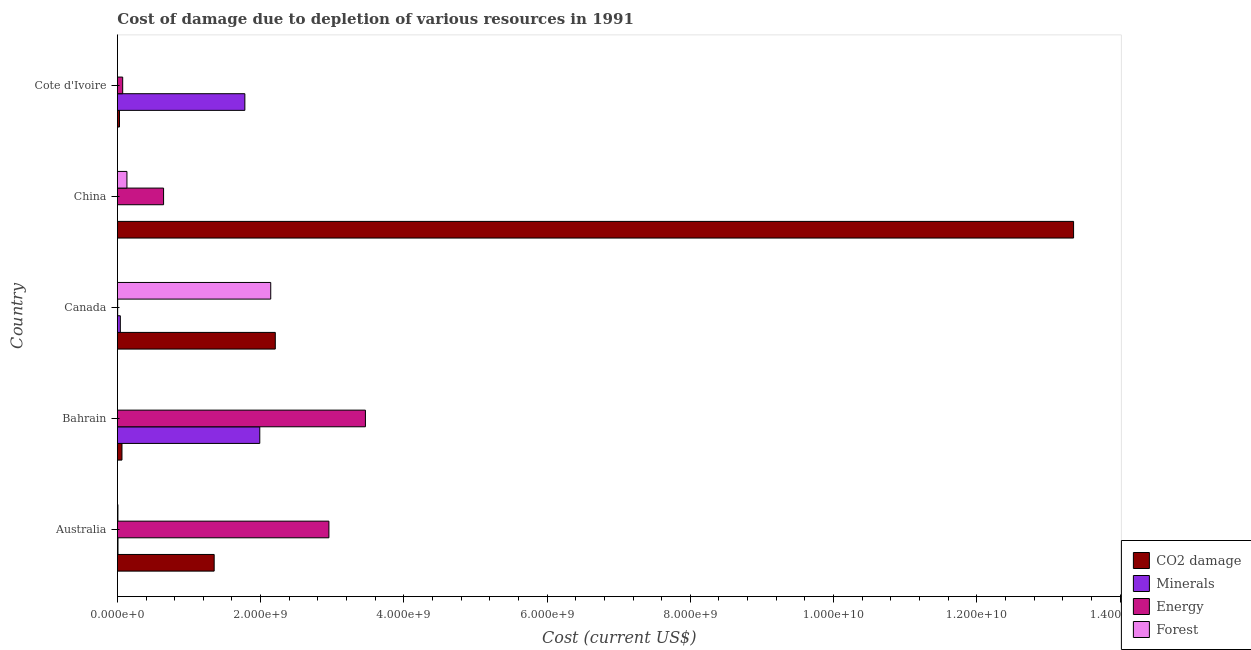How many different coloured bars are there?
Your answer should be very brief. 4. Are the number of bars on each tick of the Y-axis equal?
Make the answer very short. Yes. How many bars are there on the 4th tick from the top?
Provide a succinct answer. 4. What is the label of the 5th group of bars from the top?
Give a very brief answer. Australia. What is the cost of damage due to depletion of energy in Cote d'Ivoire?
Provide a succinct answer. 7.38e+07. Across all countries, what is the maximum cost of damage due to depletion of minerals?
Ensure brevity in your answer.  1.99e+09. Across all countries, what is the minimum cost of damage due to depletion of coal?
Keep it short and to the point. 2.91e+07. In which country was the cost of damage due to depletion of minerals maximum?
Your answer should be very brief. Bahrain. In which country was the cost of damage due to depletion of forests minimum?
Ensure brevity in your answer.  Bahrain. What is the total cost of damage due to depletion of minerals in the graph?
Keep it short and to the point. 3.82e+09. What is the difference between the cost of damage due to depletion of minerals in Bahrain and that in China?
Your response must be concise. 1.99e+09. What is the difference between the cost of damage due to depletion of forests in Cote d'Ivoire and the cost of damage due to depletion of coal in Bahrain?
Provide a succinct answer. -6.35e+07. What is the average cost of damage due to depletion of minerals per country?
Keep it short and to the point. 7.63e+08. What is the difference between the cost of damage due to depletion of coal and cost of damage due to depletion of forests in Australia?
Offer a very short reply. 1.34e+09. In how many countries, is the cost of damage due to depletion of minerals greater than 12800000000 US$?
Ensure brevity in your answer.  0. What is the ratio of the cost of damage due to depletion of forests in Canada to that in China?
Your answer should be very brief. 16.08. What is the difference between the highest and the second highest cost of damage due to depletion of coal?
Ensure brevity in your answer.  1.11e+1. What is the difference between the highest and the lowest cost of damage due to depletion of minerals?
Offer a very short reply. 1.99e+09. Is the sum of the cost of damage due to depletion of minerals in Bahrain and Cote d'Ivoire greater than the maximum cost of damage due to depletion of forests across all countries?
Provide a short and direct response. Yes. Is it the case that in every country, the sum of the cost of damage due to depletion of energy and cost of damage due to depletion of minerals is greater than the sum of cost of damage due to depletion of coal and cost of damage due to depletion of forests?
Offer a very short reply. No. What does the 1st bar from the top in Canada represents?
Your answer should be very brief. Forest. What does the 2nd bar from the bottom in Bahrain represents?
Your response must be concise. Minerals. How many bars are there?
Your answer should be compact. 20. Are all the bars in the graph horizontal?
Ensure brevity in your answer.  Yes. What is the difference between two consecutive major ticks on the X-axis?
Give a very brief answer. 2.00e+09. Are the values on the major ticks of X-axis written in scientific E-notation?
Offer a very short reply. Yes. Where does the legend appear in the graph?
Your response must be concise. Bottom right. How are the legend labels stacked?
Ensure brevity in your answer.  Vertical. What is the title of the graph?
Your answer should be very brief. Cost of damage due to depletion of various resources in 1991 . What is the label or title of the X-axis?
Provide a succinct answer. Cost (current US$). What is the label or title of the Y-axis?
Provide a succinct answer. Country. What is the Cost (current US$) of CO2 damage in Australia?
Offer a terse response. 1.35e+09. What is the Cost (current US$) in Minerals in Australia?
Your answer should be compact. 8.34e+06. What is the Cost (current US$) of Energy in Australia?
Offer a terse response. 2.95e+09. What is the Cost (current US$) in Forest in Australia?
Your answer should be very brief. 7.24e+06. What is the Cost (current US$) in CO2 damage in Bahrain?
Provide a short and direct response. 6.37e+07. What is the Cost (current US$) in Minerals in Bahrain?
Provide a short and direct response. 1.99e+09. What is the Cost (current US$) of Energy in Bahrain?
Provide a short and direct response. 3.46e+09. What is the Cost (current US$) of Forest in Bahrain?
Give a very brief answer. 1.90e+05. What is the Cost (current US$) in CO2 damage in Canada?
Provide a short and direct response. 2.20e+09. What is the Cost (current US$) in Minerals in Canada?
Make the answer very short. 4.08e+07. What is the Cost (current US$) of Energy in Canada?
Make the answer very short. 3.73e+06. What is the Cost (current US$) of Forest in Canada?
Your response must be concise. 2.14e+09. What is the Cost (current US$) of CO2 damage in China?
Your answer should be very brief. 1.34e+1. What is the Cost (current US$) in Minerals in China?
Ensure brevity in your answer.  5762.35. What is the Cost (current US$) of Energy in China?
Provide a short and direct response. 6.45e+08. What is the Cost (current US$) of Forest in China?
Offer a terse response. 1.33e+08. What is the Cost (current US$) of CO2 damage in Cote d'Ivoire?
Ensure brevity in your answer.  2.91e+07. What is the Cost (current US$) of Minerals in Cote d'Ivoire?
Ensure brevity in your answer.  1.78e+09. What is the Cost (current US$) in Energy in Cote d'Ivoire?
Provide a succinct answer. 7.38e+07. What is the Cost (current US$) in Forest in Cote d'Ivoire?
Keep it short and to the point. 2.44e+05. Across all countries, what is the maximum Cost (current US$) of CO2 damage?
Your response must be concise. 1.34e+1. Across all countries, what is the maximum Cost (current US$) in Minerals?
Your answer should be compact. 1.99e+09. Across all countries, what is the maximum Cost (current US$) of Energy?
Your answer should be very brief. 3.46e+09. Across all countries, what is the maximum Cost (current US$) of Forest?
Ensure brevity in your answer.  2.14e+09. Across all countries, what is the minimum Cost (current US$) of CO2 damage?
Your answer should be very brief. 2.91e+07. Across all countries, what is the minimum Cost (current US$) in Minerals?
Give a very brief answer. 5762.35. Across all countries, what is the minimum Cost (current US$) in Energy?
Your answer should be very brief. 3.73e+06. Across all countries, what is the minimum Cost (current US$) in Forest?
Offer a very short reply. 1.90e+05. What is the total Cost (current US$) of CO2 damage in the graph?
Your answer should be very brief. 1.70e+1. What is the total Cost (current US$) in Minerals in the graph?
Your answer should be very brief. 3.82e+09. What is the total Cost (current US$) in Energy in the graph?
Provide a short and direct response. 7.14e+09. What is the total Cost (current US$) in Forest in the graph?
Make the answer very short. 2.28e+09. What is the difference between the Cost (current US$) in CO2 damage in Australia and that in Bahrain?
Give a very brief answer. 1.29e+09. What is the difference between the Cost (current US$) of Minerals in Australia and that in Bahrain?
Give a very brief answer. -1.98e+09. What is the difference between the Cost (current US$) in Energy in Australia and that in Bahrain?
Keep it short and to the point. -5.10e+08. What is the difference between the Cost (current US$) of Forest in Australia and that in Bahrain?
Offer a very short reply. 7.05e+06. What is the difference between the Cost (current US$) in CO2 damage in Australia and that in Canada?
Your answer should be compact. -8.53e+08. What is the difference between the Cost (current US$) in Minerals in Australia and that in Canada?
Give a very brief answer. -3.24e+07. What is the difference between the Cost (current US$) in Energy in Australia and that in Canada?
Keep it short and to the point. 2.95e+09. What is the difference between the Cost (current US$) of Forest in Australia and that in Canada?
Your answer should be compact. -2.13e+09. What is the difference between the Cost (current US$) of CO2 damage in Australia and that in China?
Offer a terse response. -1.20e+1. What is the difference between the Cost (current US$) in Minerals in Australia and that in China?
Give a very brief answer. 8.33e+06. What is the difference between the Cost (current US$) in Energy in Australia and that in China?
Ensure brevity in your answer.  2.31e+09. What is the difference between the Cost (current US$) in Forest in Australia and that in China?
Keep it short and to the point. -1.26e+08. What is the difference between the Cost (current US$) of CO2 damage in Australia and that in Cote d'Ivoire?
Ensure brevity in your answer.  1.32e+09. What is the difference between the Cost (current US$) of Minerals in Australia and that in Cote d'Ivoire?
Ensure brevity in your answer.  -1.77e+09. What is the difference between the Cost (current US$) in Energy in Australia and that in Cote d'Ivoire?
Offer a terse response. 2.88e+09. What is the difference between the Cost (current US$) of Forest in Australia and that in Cote d'Ivoire?
Offer a terse response. 7.00e+06. What is the difference between the Cost (current US$) of CO2 damage in Bahrain and that in Canada?
Your answer should be very brief. -2.14e+09. What is the difference between the Cost (current US$) of Minerals in Bahrain and that in Canada?
Provide a succinct answer. 1.95e+09. What is the difference between the Cost (current US$) in Energy in Bahrain and that in Canada?
Your answer should be very brief. 3.46e+09. What is the difference between the Cost (current US$) in Forest in Bahrain and that in Canada?
Make the answer very short. -2.14e+09. What is the difference between the Cost (current US$) of CO2 damage in Bahrain and that in China?
Ensure brevity in your answer.  -1.33e+1. What is the difference between the Cost (current US$) of Minerals in Bahrain and that in China?
Provide a succinct answer. 1.99e+09. What is the difference between the Cost (current US$) in Energy in Bahrain and that in China?
Your answer should be compact. 2.82e+09. What is the difference between the Cost (current US$) of Forest in Bahrain and that in China?
Your answer should be very brief. -1.33e+08. What is the difference between the Cost (current US$) in CO2 damage in Bahrain and that in Cote d'Ivoire?
Offer a very short reply. 3.46e+07. What is the difference between the Cost (current US$) in Minerals in Bahrain and that in Cote d'Ivoire?
Offer a very short reply. 2.08e+08. What is the difference between the Cost (current US$) in Energy in Bahrain and that in Cote d'Ivoire?
Keep it short and to the point. 3.39e+09. What is the difference between the Cost (current US$) of Forest in Bahrain and that in Cote d'Ivoire?
Your answer should be compact. -5.42e+04. What is the difference between the Cost (current US$) in CO2 damage in Canada and that in China?
Your answer should be compact. -1.11e+1. What is the difference between the Cost (current US$) in Minerals in Canada and that in China?
Your answer should be compact. 4.08e+07. What is the difference between the Cost (current US$) of Energy in Canada and that in China?
Offer a very short reply. -6.41e+08. What is the difference between the Cost (current US$) of Forest in Canada and that in China?
Ensure brevity in your answer.  2.01e+09. What is the difference between the Cost (current US$) of CO2 damage in Canada and that in Cote d'Ivoire?
Keep it short and to the point. 2.18e+09. What is the difference between the Cost (current US$) of Minerals in Canada and that in Cote d'Ivoire?
Offer a terse response. -1.74e+09. What is the difference between the Cost (current US$) in Energy in Canada and that in Cote d'Ivoire?
Make the answer very short. -7.01e+07. What is the difference between the Cost (current US$) in Forest in Canada and that in Cote d'Ivoire?
Give a very brief answer. 2.14e+09. What is the difference between the Cost (current US$) in CO2 damage in China and that in Cote d'Ivoire?
Your answer should be very brief. 1.33e+1. What is the difference between the Cost (current US$) of Minerals in China and that in Cote d'Ivoire?
Make the answer very short. -1.78e+09. What is the difference between the Cost (current US$) of Energy in China and that in Cote d'Ivoire?
Offer a very short reply. 5.71e+08. What is the difference between the Cost (current US$) of Forest in China and that in Cote d'Ivoire?
Provide a short and direct response. 1.33e+08. What is the difference between the Cost (current US$) in CO2 damage in Australia and the Cost (current US$) in Minerals in Bahrain?
Offer a terse response. -6.37e+08. What is the difference between the Cost (current US$) in CO2 damage in Australia and the Cost (current US$) in Energy in Bahrain?
Keep it short and to the point. -2.11e+09. What is the difference between the Cost (current US$) in CO2 damage in Australia and the Cost (current US$) in Forest in Bahrain?
Keep it short and to the point. 1.35e+09. What is the difference between the Cost (current US$) in Minerals in Australia and the Cost (current US$) in Energy in Bahrain?
Your answer should be compact. -3.45e+09. What is the difference between the Cost (current US$) of Minerals in Australia and the Cost (current US$) of Forest in Bahrain?
Offer a very short reply. 8.15e+06. What is the difference between the Cost (current US$) in Energy in Australia and the Cost (current US$) in Forest in Bahrain?
Offer a very short reply. 2.95e+09. What is the difference between the Cost (current US$) of CO2 damage in Australia and the Cost (current US$) of Minerals in Canada?
Give a very brief answer. 1.31e+09. What is the difference between the Cost (current US$) of CO2 damage in Australia and the Cost (current US$) of Energy in Canada?
Your answer should be compact. 1.35e+09. What is the difference between the Cost (current US$) in CO2 damage in Australia and the Cost (current US$) in Forest in Canada?
Provide a succinct answer. -7.90e+08. What is the difference between the Cost (current US$) of Minerals in Australia and the Cost (current US$) of Energy in Canada?
Give a very brief answer. 4.61e+06. What is the difference between the Cost (current US$) in Minerals in Australia and the Cost (current US$) in Forest in Canada?
Make the answer very short. -2.13e+09. What is the difference between the Cost (current US$) in Energy in Australia and the Cost (current US$) in Forest in Canada?
Provide a short and direct response. 8.12e+08. What is the difference between the Cost (current US$) of CO2 damage in Australia and the Cost (current US$) of Minerals in China?
Your answer should be compact. 1.35e+09. What is the difference between the Cost (current US$) in CO2 damage in Australia and the Cost (current US$) in Energy in China?
Give a very brief answer. 7.06e+08. What is the difference between the Cost (current US$) of CO2 damage in Australia and the Cost (current US$) of Forest in China?
Offer a very short reply. 1.22e+09. What is the difference between the Cost (current US$) of Minerals in Australia and the Cost (current US$) of Energy in China?
Your response must be concise. -6.37e+08. What is the difference between the Cost (current US$) in Minerals in Australia and the Cost (current US$) in Forest in China?
Offer a very short reply. -1.25e+08. What is the difference between the Cost (current US$) of Energy in Australia and the Cost (current US$) of Forest in China?
Your response must be concise. 2.82e+09. What is the difference between the Cost (current US$) of CO2 damage in Australia and the Cost (current US$) of Minerals in Cote d'Ivoire?
Your answer should be compact. -4.28e+08. What is the difference between the Cost (current US$) in CO2 damage in Australia and the Cost (current US$) in Energy in Cote d'Ivoire?
Offer a very short reply. 1.28e+09. What is the difference between the Cost (current US$) of CO2 damage in Australia and the Cost (current US$) of Forest in Cote d'Ivoire?
Ensure brevity in your answer.  1.35e+09. What is the difference between the Cost (current US$) of Minerals in Australia and the Cost (current US$) of Energy in Cote d'Ivoire?
Offer a very short reply. -6.55e+07. What is the difference between the Cost (current US$) in Minerals in Australia and the Cost (current US$) in Forest in Cote d'Ivoire?
Provide a short and direct response. 8.09e+06. What is the difference between the Cost (current US$) in Energy in Australia and the Cost (current US$) in Forest in Cote d'Ivoire?
Ensure brevity in your answer.  2.95e+09. What is the difference between the Cost (current US$) of CO2 damage in Bahrain and the Cost (current US$) of Minerals in Canada?
Give a very brief answer. 2.29e+07. What is the difference between the Cost (current US$) of CO2 damage in Bahrain and the Cost (current US$) of Energy in Canada?
Your answer should be very brief. 6.00e+07. What is the difference between the Cost (current US$) in CO2 damage in Bahrain and the Cost (current US$) in Forest in Canada?
Your answer should be very brief. -2.08e+09. What is the difference between the Cost (current US$) in Minerals in Bahrain and the Cost (current US$) in Energy in Canada?
Provide a succinct answer. 1.98e+09. What is the difference between the Cost (current US$) in Minerals in Bahrain and the Cost (current US$) in Forest in Canada?
Offer a terse response. -1.53e+08. What is the difference between the Cost (current US$) in Energy in Bahrain and the Cost (current US$) in Forest in Canada?
Your answer should be compact. 1.32e+09. What is the difference between the Cost (current US$) of CO2 damage in Bahrain and the Cost (current US$) of Minerals in China?
Your answer should be compact. 6.37e+07. What is the difference between the Cost (current US$) of CO2 damage in Bahrain and the Cost (current US$) of Energy in China?
Your answer should be very brief. -5.81e+08. What is the difference between the Cost (current US$) of CO2 damage in Bahrain and the Cost (current US$) of Forest in China?
Keep it short and to the point. -6.94e+07. What is the difference between the Cost (current US$) in Minerals in Bahrain and the Cost (current US$) in Energy in China?
Provide a succinct answer. 1.34e+09. What is the difference between the Cost (current US$) in Minerals in Bahrain and the Cost (current US$) in Forest in China?
Give a very brief answer. 1.86e+09. What is the difference between the Cost (current US$) of Energy in Bahrain and the Cost (current US$) of Forest in China?
Your answer should be compact. 3.33e+09. What is the difference between the Cost (current US$) of CO2 damage in Bahrain and the Cost (current US$) of Minerals in Cote d'Ivoire?
Your answer should be very brief. -1.72e+09. What is the difference between the Cost (current US$) in CO2 damage in Bahrain and the Cost (current US$) in Energy in Cote d'Ivoire?
Give a very brief answer. -1.01e+07. What is the difference between the Cost (current US$) in CO2 damage in Bahrain and the Cost (current US$) in Forest in Cote d'Ivoire?
Your answer should be very brief. 6.35e+07. What is the difference between the Cost (current US$) of Minerals in Bahrain and the Cost (current US$) of Energy in Cote d'Ivoire?
Keep it short and to the point. 1.91e+09. What is the difference between the Cost (current US$) of Minerals in Bahrain and the Cost (current US$) of Forest in Cote d'Ivoire?
Ensure brevity in your answer.  1.99e+09. What is the difference between the Cost (current US$) of Energy in Bahrain and the Cost (current US$) of Forest in Cote d'Ivoire?
Your answer should be very brief. 3.46e+09. What is the difference between the Cost (current US$) in CO2 damage in Canada and the Cost (current US$) in Minerals in China?
Offer a very short reply. 2.20e+09. What is the difference between the Cost (current US$) of CO2 damage in Canada and the Cost (current US$) of Energy in China?
Your answer should be compact. 1.56e+09. What is the difference between the Cost (current US$) of CO2 damage in Canada and the Cost (current US$) of Forest in China?
Offer a very short reply. 2.07e+09. What is the difference between the Cost (current US$) in Minerals in Canada and the Cost (current US$) in Energy in China?
Make the answer very short. -6.04e+08. What is the difference between the Cost (current US$) in Minerals in Canada and the Cost (current US$) in Forest in China?
Give a very brief answer. -9.24e+07. What is the difference between the Cost (current US$) in Energy in Canada and the Cost (current US$) in Forest in China?
Provide a short and direct response. -1.29e+08. What is the difference between the Cost (current US$) of CO2 damage in Canada and the Cost (current US$) of Minerals in Cote d'Ivoire?
Offer a very short reply. 4.25e+08. What is the difference between the Cost (current US$) in CO2 damage in Canada and the Cost (current US$) in Energy in Cote d'Ivoire?
Provide a succinct answer. 2.13e+09. What is the difference between the Cost (current US$) of CO2 damage in Canada and the Cost (current US$) of Forest in Cote d'Ivoire?
Your answer should be compact. 2.20e+09. What is the difference between the Cost (current US$) in Minerals in Canada and the Cost (current US$) in Energy in Cote d'Ivoire?
Keep it short and to the point. -3.31e+07. What is the difference between the Cost (current US$) in Minerals in Canada and the Cost (current US$) in Forest in Cote d'Ivoire?
Make the answer very short. 4.05e+07. What is the difference between the Cost (current US$) of Energy in Canada and the Cost (current US$) of Forest in Cote d'Ivoire?
Provide a short and direct response. 3.48e+06. What is the difference between the Cost (current US$) of CO2 damage in China and the Cost (current US$) of Minerals in Cote d'Ivoire?
Provide a succinct answer. 1.16e+1. What is the difference between the Cost (current US$) in CO2 damage in China and the Cost (current US$) in Energy in Cote d'Ivoire?
Provide a succinct answer. 1.33e+1. What is the difference between the Cost (current US$) in CO2 damage in China and the Cost (current US$) in Forest in Cote d'Ivoire?
Your response must be concise. 1.34e+1. What is the difference between the Cost (current US$) of Minerals in China and the Cost (current US$) of Energy in Cote d'Ivoire?
Your response must be concise. -7.38e+07. What is the difference between the Cost (current US$) of Minerals in China and the Cost (current US$) of Forest in Cote d'Ivoire?
Ensure brevity in your answer.  -2.39e+05. What is the difference between the Cost (current US$) in Energy in China and the Cost (current US$) in Forest in Cote d'Ivoire?
Provide a succinct answer. 6.45e+08. What is the average Cost (current US$) of CO2 damage per country?
Give a very brief answer. 3.40e+09. What is the average Cost (current US$) in Minerals per country?
Your response must be concise. 7.63e+08. What is the average Cost (current US$) in Energy per country?
Ensure brevity in your answer.  1.43e+09. What is the average Cost (current US$) of Forest per country?
Your answer should be very brief. 4.56e+08. What is the difference between the Cost (current US$) of CO2 damage and Cost (current US$) of Minerals in Australia?
Offer a terse response. 1.34e+09. What is the difference between the Cost (current US$) in CO2 damage and Cost (current US$) in Energy in Australia?
Give a very brief answer. -1.60e+09. What is the difference between the Cost (current US$) in CO2 damage and Cost (current US$) in Forest in Australia?
Keep it short and to the point. 1.34e+09. What is the difference between the Cost (current US$) in Minerals and Cost (current US$) in Energy in Australia?
Your answer should be compact. -2.95e+09. What is the difference between the Cost (current US$) in Minerals and Cost (current US$) in Forest in Australia?
Ensure brevity in your answer.  1.10e+06. What is the difference between the Cost (current US$) of Energy and Cost (current US$) of Forest in Australia?
Your answer should be compact. 2.95e+09. What is the difference between the Cost (current US$) in CO2 damage and Cost (current US$) in Minerals in Bahrain?
Give a very brief answer. -1.92e+09. What is the difference between the Cost (current US$) in CO2 damage and Cost (current US$) in Energy in Bahrain?
Keep it short and to the point. -3.40e+09. What is the difference between the Cost (current US$) of CO2 damage and Cost (current US$) of Forest in Bahrain?
Keep it short and to the point. 6.35e+07. What is the difference between the Cost (current US$) in Minerals and Cost (current US$) in Energy in Bahrain?
Offer a terse response. -1.48e+09. What is the difference between the Cost (current US$) of Minerals and Cost (current US$) of Forest in Bahrain?
Give a very brief answer. 1.99e+09. What is the difference between the Cost (current US$) in Energy and Cost (current US$) in Forest in Bahrain?
Your response must be concise. 3.46e+09. What is the difference between the Cost (current US$) in CO2 damage and Cost (current US$) in Minerals in Canada?
Make the answer very short. 2.16e+09. What is the difference between the Cost (current US$) of CO2 damage and Cost (current US$) of Energy in Canada?
Offer a very short reply. 2.20e+09. What is the difference between the Cost (current US$) in CO2 damage and Cost (current US$) in Forest in Canada?
Ensure brevity in your answer.  6.37e+07. What is the difference between the Cost (current US$) of Minerals and Cost (current US$) of Energy in Canada?
Keep it short and to the point. 3.71e+07. What is the difference between the Cost (current US$) in Minerals and Cost (current US$) in Forest in Canada?
Provide a succinct answer. -2.10e+09. What is the difference between the Cost (current US$) of Energy and Cost (current US$) of Forest in Canada?
Make the answer very short. -2.14e+09. What is the difference between the Cost (current US$) of CO2 damage and Cost (current US$) of Minerals in China?
Provide a short and direct response. 1.34e+1. What is the difference between the Cost (current US$) of CO2 damage and Cost (current US$) of Energy in China?
Give a very brief answer. 1.27e+1. What is the difference between the Cost (current US$) of CO2 damage and Cost (current US$) of Forest in China?
Offer a very short reply. 1.32e+1. What is the difference between the Cost (current US$) in Minerals and Cost (current US$) in Energy in China?
Give a very brief answer. -6.45e+08. What is the difference between the Cost (current US$) in Minerals and Cost (current US$) in Forest in China?
Ensure brevity in your answer.  -1.33e+08. What is the difference between the Cost (current US$) of Energy and Cost (current US$) of Forest in China?
Make the answer very short. 5.12e+08. What is the difference between the Cost (current US$) of CO2 damage and Cost (current US$) of Minerals in Cote d'Ivoire?
Offer a terse response. -1.75e+09. What is the difference between the Cost (current US$) of CO2 damage and Cost (current US$) of Energy in Cote d'Ivoire?
Offer a terse response. -4.47e+07. What is the difference between the Cost (current US$) of CO2 damage and Cost (current US$) of Forest in Cote d'Ivoire?
Offer a very short reply. 2.89e+07. What is the difference between the Cost (current US$) of Minerals and Cost (current US$) of Energy in Cote d'Ivoire?
Provide a short and direct response. 1.71e+09. What is the difference between the Cost (current US$) in Minerals and Cost (current US$) in Forest in Cote d'Ivoire?
Your answer should be compact. 1.78e+09. What is the difference between the Cost (current US$) of Energy and Cost (current US$) of Forest in Cote d'Ivoire?
Offer a very short reply. 7.36e+07. What is the ratio of the Cost (current US$) in CO2 damage in Australia to that in Bahrain?
Make the answer very short. 21.2. What is the ratio of the Cost (current US$) in Minerals in Australia to that in Bahrain?
Keep it short and to the point. 0. What is the ratio of the Cost (current US$) of Energy in Australia to that in Bahrain?
Your answer should be compact. 0.85. What is the ratio of the Cost (current US$) in Forest in Australia to that in Bahrain?
Offer a terse response. 38.1. What is the ratio of the Cost (current US$) in CO2 damage in Australia to that in Canada?
Ensure brevity in your answer.  0.61. What is the ratio of the Cost (current US$) in Minerals in Australia to that in Canada?
Provide a succinct answer. 0.2. What is the ratio of the Cost (current US$) in Energy in Australia to that in Canada?
Your answer should be very brief. 792.69. What is the ratio of the Cost (current US$) in Forest in Australia to that in Canada?
Your answer should be compact. 0. What is the ratio of the Cost (current US$) of CO2 damage in Australia to that in China?
Ensure brevity in your answer.  0.1. What is the ratio of the Cost (current US$) in Minerals in Australia to that in China?
Ensure brevity in your answer.  1447.04. What is the ratio of the Cost (current US$) of Energy in Australia to that in China?
Your response must be concise. 4.58. What is the ratio of the Cost (current US$) in Forest in Australia to that in China?
Your answer should be very brief. 0.05. What is the ratio of the Cost (current US$) of CO2 damage in Australia to that in Cote d'Ivoire?
Your answer should be compact. 46.41. What is the ratio of the Cost (current US$) in Minerals in Australia to that in Cote d'Ivoire?
Provide a succinct answer. 0. What is the ratio of the Cost (current US$) in Energy in Australia to that in Cote d'Ivoire?
Offer a terse response. 40. What is the ratio of the Cost (current US$) of Forest in Australia to that in Cote d'Ivoire?
Your answer should be compact. 29.64. What is the ratio of the Cost (current US$) in CO2 damage in Bahrain to that in Canada?
Provide a short and direct response. 0.03. What is the ratio of the Cost (current US$) of Minerals in Bahrain to that in Canada?
Ensure brevity in your answer.  48.76. What is the ratio of the Cost (current US$) in Energy in Bahrain to that in Canada?
Give a very brief answer. 929.54. What is the ratio of the Cost (current US$) of CO2 damage in Bahrain to that in China?
Your response must be concise. 0. What is the ratio of the Cost (current US$) in Minerals in Bahrain to that in China?
Offer a terse response. 3.45e+05. What is the ratio of the Cost (current US$) in Energy in Bahrain to that in China?
Your answer should be very brief. 5.37. What is the ratio of the Cost (current US$) in Forest in Bahrain to that in China?
Make the answer very short. 0. What is the ratio of the Cost (current US$) of CO2 damage in Bahrain to that in Cote d'Ivoire?
Give a very brief answer. 2.19. What is the ratio of the Cost (current US$) of Minerals in Bahrain to that in Cote d'Ivoire?
Your answer should be compact. 1.12. What is the ratio of the Cost (current US$) of Energy in Bahrain to that in Cote d'Ivoire?
Offer a very short reply. 46.91. What is the ratio of the Cost (current US$) in Forest in Bahrain to that in Cote d'Ivoire?
Keep it short and to the point. 0.78. What is the ratio of the Cost (current US$) of CO2 damage in Canada to that in China?
Provide a succinct answer. 0.17. What is the ratio of the Cost (current US$) of Minerals in Canada to that in China?
Keep it short and to the point. 7076.47. What is the ratio of the Cost (current US$) of Energy in Canada to that in China?
Your response must be concise. 0.01. What is the ratio of the Cost (current US$) in Forest in Canada to that in China?
Your answer should be compact. 16.08. What is the ratio of the Cost (current US$) in CO2 damage in Canada to that in Cote d'Ivoire?
Give a very brief answer. 75.72. What is the ratio of the Cost (current US$) of Minerals in Canada to that in Cote d'Ivoire?
Ensure brevity in your answer.  0.02. What is the ratio of the Cost (current US$) in Energy in Canada to that in Cote d'Ivoire?
Ensure brevity in your answer.  0.05. What is the ratio of the Cost (current US$) of Forest in Canada to that in Cote d'Ivoire?
Offer a very short reply. 8764.71. What is the ratio of the Cost (current US$) in CO2 damage in China to that in Cote d'Ivoire?
Your answer should be very brief. 458.56. What is the ratio of the Cost (current US$) in Energy in China to that in Cote d'Ivoire?
Give a very brief answer. 8.73. What is the ratio of the Cost (current US$) of Forest in China to that in Cote d'Ivoire?
Your response must be concise. 545.01. What is the difference between the highest and the second highest Cost (current US$) in CO2 damage?
Make the answer very short. 1.11e+1. What is the difference between the highest and the second highest Cost (current US$) in Minerals?
Provide a succinct answer. 2.08e+08. What is the difference between the highest and the second highest Cost (current US$) in Energy?
Make the answer very short. 5.10e+08. What is the difference between the highest and the second highest Cost (current US$) in Forest?
Give a very brief answer. 2.01e+09. What is the difference between the highest and the lowest Cost (current US$) in CO2 damage?
Offer a terse response. 1.33e+1. What is the difference between the highest and the lowest Cost (current US$) in Minerals?
Make the answer very short. 1.99e+09. What is the difference between the highest and the lowest Cost (current US$) in Energy?
Ensure brevity in your answer.  3.46e+09. What is the difference between the highest and the lowest Cost (current US$) of Forest?
Offer a very short reply. 2.14e+09. 